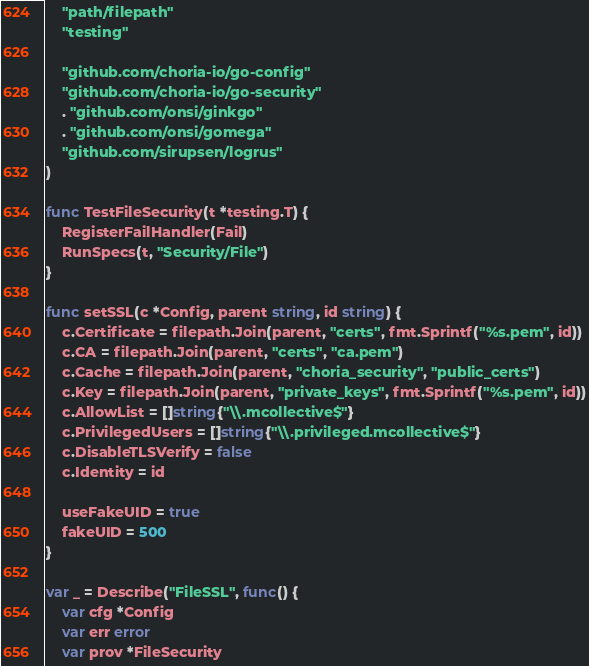Convert code to text. <code><loc_0><loc_0><loc_500><loc_500><_Go_>	"path/filepath"
	"testing"

	"github.com/choria-io/go-config"
	"github.com/choria-io/go-security"
	. "github.com/onsi/ginkgo"
	. "github.com/onsi/gomega"
	"github.com/sirupsen/logrus"
)

func TestFileSecurity(t *testing.T) {
	RegisterFailHandler(Fail)
	RunSpecs(t, "Security/File")
}

func setSSL(c *Config, parent string, id string) {
	c.Certificate = filepath.Join(parent, "certs", fmt.Sprintf("%s.pem", id))
	c.CA = filepath.Join(parent, "certs", "ca.pem")
	c.Cache = filepath.Join(parent, "choria_security", "public_certs")
	c.Key = filepath.Join(parent, "private_keys", fmt.Sprintf("%s.pem", id))
	c.AllowList = []string{"\\.mcollective$"}
	c.PrivilegedUsers = []string{"\\.privileged.mcollective$"}
	c.DisableTLSVerify = false
	c.Identity = id

	useFakeUID = true
	fakeUID = 500
}

var _ = Describe("FileSSL", func() {
	var cfg *Config
	var err error
	var prov *FileSecurity</code> 